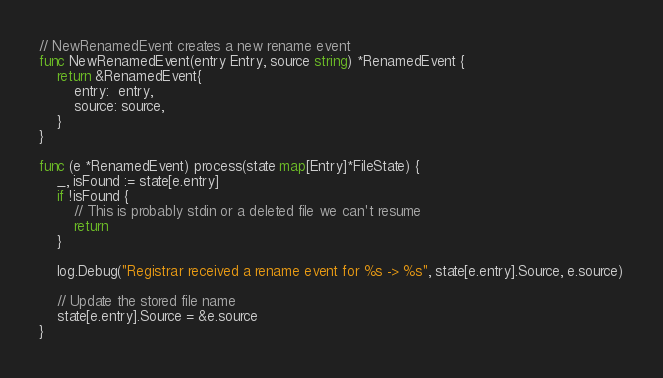Convert code to text. <code><loc_0><loc_0><loc_500><loc_500><_Go_>
// NewRenamedEvent creates a new rename event
func NewRenamedEvent(entry Entry, source string) *RenamedEvent {
	return &RenamedEvent{
		entry:  entry,
		source: source,
	}
}

func (e *RenamedEvent) process(state map[Entry]*FileState) {
	_, isFound := state[e.entry]
	if !isFound {
		// This is probably stdin or a deleted file we can't resume
		return
	}

	log.Debug("Registrar received a rename event for %s -> %s", state[e.entry].Source, e.source)

	// Update the stored file name
	state[e.entry].Source = &e.source
}
</code> 